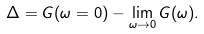Convert formula to latex. <formula><loc_0><loc_0><loc_500><loc_500>\Delta = G ( \omega = 0 ) - \lim _ { \omega \to 0 } G ( \omega ) .</formula> 